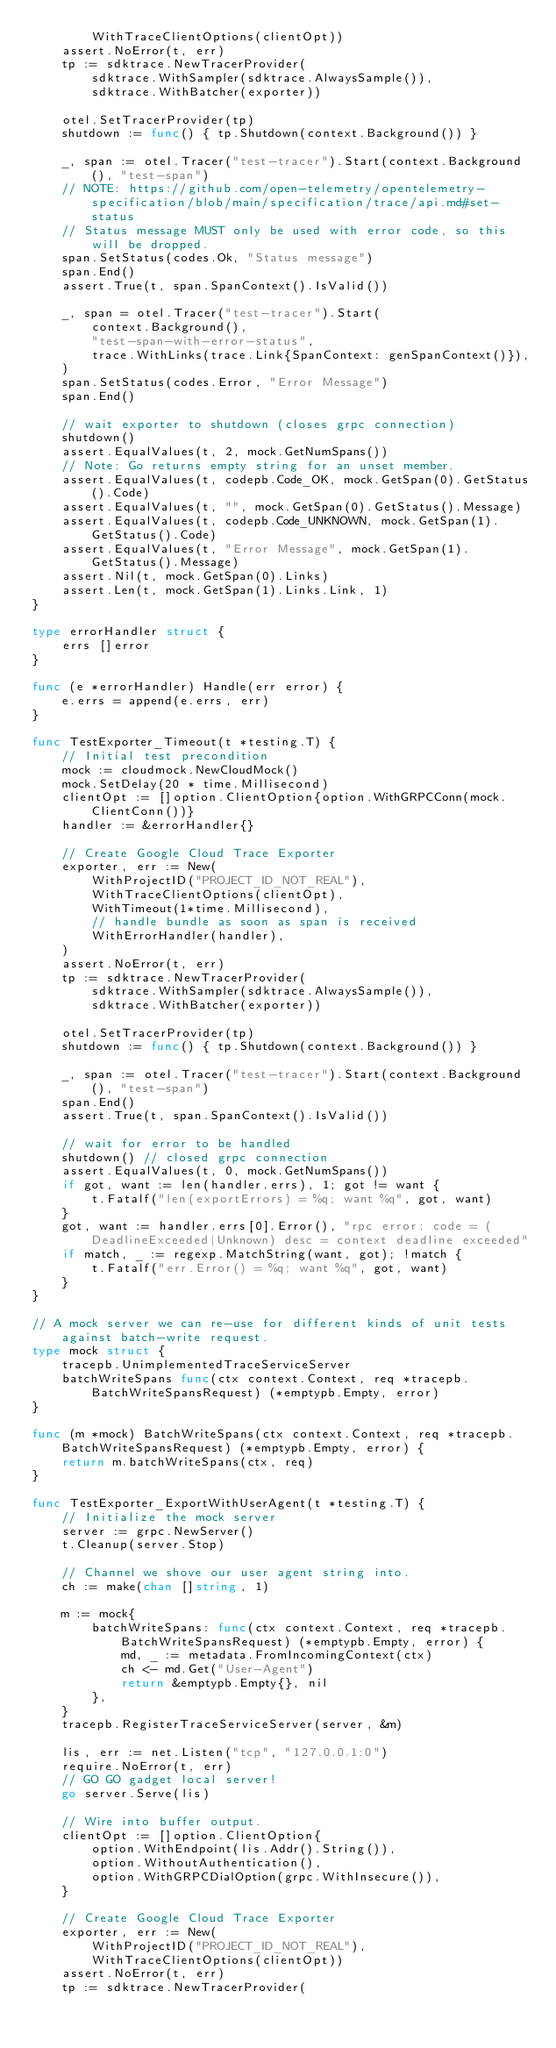<code> <loc_0><loc_0><loc_500><loc_500><_Go_>		WithTraceClientOptions(clientOpt))
	assert.NoError(t, err)
	tp := sdktrace.NewTracerProvider(
		sdktrace.WithSampler(sdktrace.AlwaysSample()),
		sdktrace.WithBatcher(exporter))

	otel.SetTracerProvider(tp)
	shutdown := func() { tp.Shutdown(context.Background()) }

	_, span := otel.Tracer("test-tracer").Start(context.Background(), "test-span")
	// NOTE: https://github.com/open-telemetry/opentelemetry-specification/blob/main/specification/trace/api.md#set-status
	// Status message MUST only be used with error code, so this will be dropped.
	span.SetStatus(codes.Ok, "Status message")
	span.End()
	assert.True(t, span.SpanContext().IsValid())

	_, span = otel.Tracer("test-tracer").Start(
		context.Background(),
		"test-span-with-error-status",
		trace.WithLinks(trace.Link{SpanContext: genSpanContext()}),
	)
	span.SetStatus(codes.Error, "Error Message")
	span.End()

	// wait exporter to shutdown (closes grpc connection)
	shutdown()
	assert.EqualValues(t, 2, mock.GetNumSpans())
	// Note: Go returns empty string for an unset member.
	assert.EqualValues(t, codepb.Code_OK, mock.GetSpan(0).GetStatus().Code)
	assert.EqualValues(t, "", mock.GetSpan(0).GetStatus().Message)
	assert.EqualValues(t, codepb.Code_UNKNOWN, mock.GetSpan(1).GetStatus().Code)
	assert.EqualValues(t, "Error Message", mock.GetSpan(1).GetStatus().Message)
	assert.Nil(t, mock.GetSpan(0).Links)
	assert.Len(t, mock.GetSpan(1).Links.Link, 1)
}

type errorHandler struct {
	errs []error
}

func (e *errorHandler) Handle(err error) {
	e.errs = append(e.errs, err)
}

func TestExporter_Timeout(t *testing.T) {
	// Initial test precondition
	mock := cloudmock.NewCloudMock()
	mock.SetDelay(20 * time.Millisecond)
	clientOpt := []option.ClientOption{option.WithGRPCConn(mock.ClientConn())}
	handler := &errorHandler{}

	// Create Google Cloud Trace Exporter
	exporter, err := New(
		WithProjectID("PROJECT_ID_NOT_REAL"),
		WithTraceClientOptions(clientOpt),
		WithTimeout(1*time.Millisecond),
		// handle bundle as soon as span is received
		WithErrorHandler(handler),
	)
	assert.NoError(t, err)
	tp := sdktrace.NewTracerProvider(
		sdktrace.WithSampler(sdktrace.AlwaysSample()),
		sdktrace.WithBatcher(exporter))

	otel.SetTracerProvider(tp)
	shutdown := func() { tp.Shutdown(context.Background()) }

	_, span := otel.Tracer("test-tracer").Start(context.Background(), "test-span")
	span.End()
	assert.True(t, span.SpanContext().IsValid())

	// wait for error to be handled
	shutdown() // closed grpc connection
	assert.EqualValues(t, 0, mock.GetNumSpans())
	if got, want := len(handler.errs), 1; got != want {
		t.Fatalf("len(exportErrors) = %q; want %q", got, want)
	}
	got, want := handler.errs[0].Error(), "rpc error: code = (DeadlineExceeded|Unknown) desc = context deadline exceeded"
	if match, _ := regexp.MatchString(want, got); !match {
		t.Fatalf("err.Error() = %q; want %q", got, want)
	}
}

// A mock server we can re-use for different kinds of unit tests against batch-write request.
type mock struct {
	tracepb.UnimplementedTraceServiceServer
	batchWriteSpans func(ctx context.Context, req *tracepb.BatchWriteSpansRequest) (*emptypb.Empty, error)
}

func (m *mock) BatchWriteSpans(ctx context.Context, req *tracepb.BatchWriteSpansRequest) (*emptypb.Empty, error) {
	return m.batchWriteSpans(ctx, req)
}

func TestExporter_ExportWithUserAgent(t *testing.T) {
	// Initialize the mock server
	server := grpc.NewServer()
	t.Cleanup(server.Stop)

	// Channel we shove our user agent string into.
	ch := make(chan []string, 1)

	m := mock{
		batchWriteSpans: func(ctx context.Context, req *tracepb.BatchWriteSpansRequest) (*emptypb.Empty, error) {
			md, _ := metadata.FromIncomingContext(ctx)
			ch <- md.Get("User-Agent")
			return &emptypb.Empty{}, nil
		},
	}
	tracepb.RegisterTraceServiceServer(server, &m)

	lis, err := net.Listen("tcp", "127.0.0.1:0")
	require.NoError(t, err)
	// GO GO gadget local server!
	go server.Serve(lis)

	// Wire into buffer output.
	clientOpt := []option.ClientOption{
		option.WithEndpoint(lis.Addr().String()),
		option.WithoutAuthentication(),
		option.WithGRPCDialOption(grpc.WithInsecure()),
	}

	// Create Google Cloud Trace Exporter
	exporter, err := New(
		WithProjectID("PROJECT_ID_NOT_REAL"),
		WithTraceClientOptions(clientOpt))
	assert.NoError(t, err)
	tp := sdktrace.NewTracerProvider(</code> 